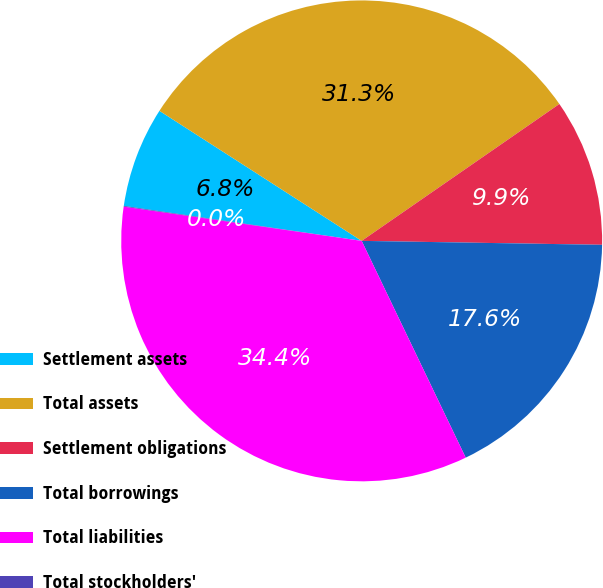Convert chart to OTSL. <chart><loc_0><loc_0><loc_500><loc_500><pie_chart><fcel>Settlement assets<fcel>Total assets<fcel>Settlement obligations<fcel>Total borrowings<fcel>Total liabilities<fcel>Total stockholders'<nl><fcel>6.77%<fcel>31.27%<fcel>9.9%<fcel>17.62%<fcel>34.4%<fcel>0.05%<nl></chart> 